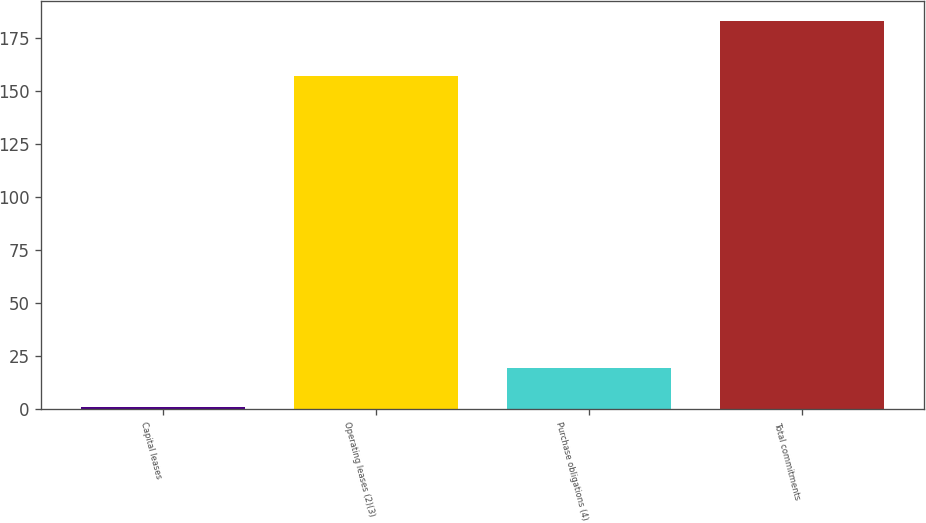Convert chart to OTSL. <chart><loc_0><loc_0><loc_500><loc_500><bar_chart><fcel>Capital leases<fcel>Operating leases (2)(3)<fcel>Purchase obligations (4)<fcel>Total commitments<nl><fcel>1<fcel>157<fcel>19.2<fcel>183<nl></chart> 